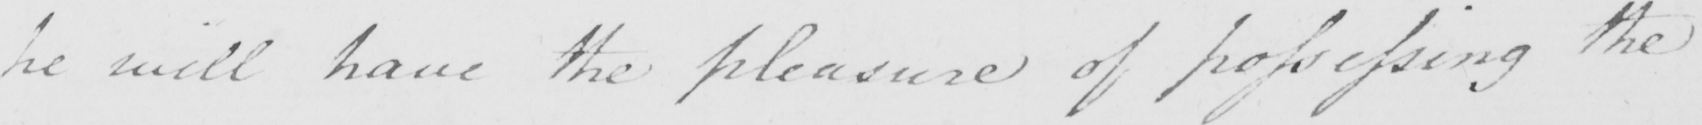What text is written in this handwritten line? he will have the pleasure of possessing the 